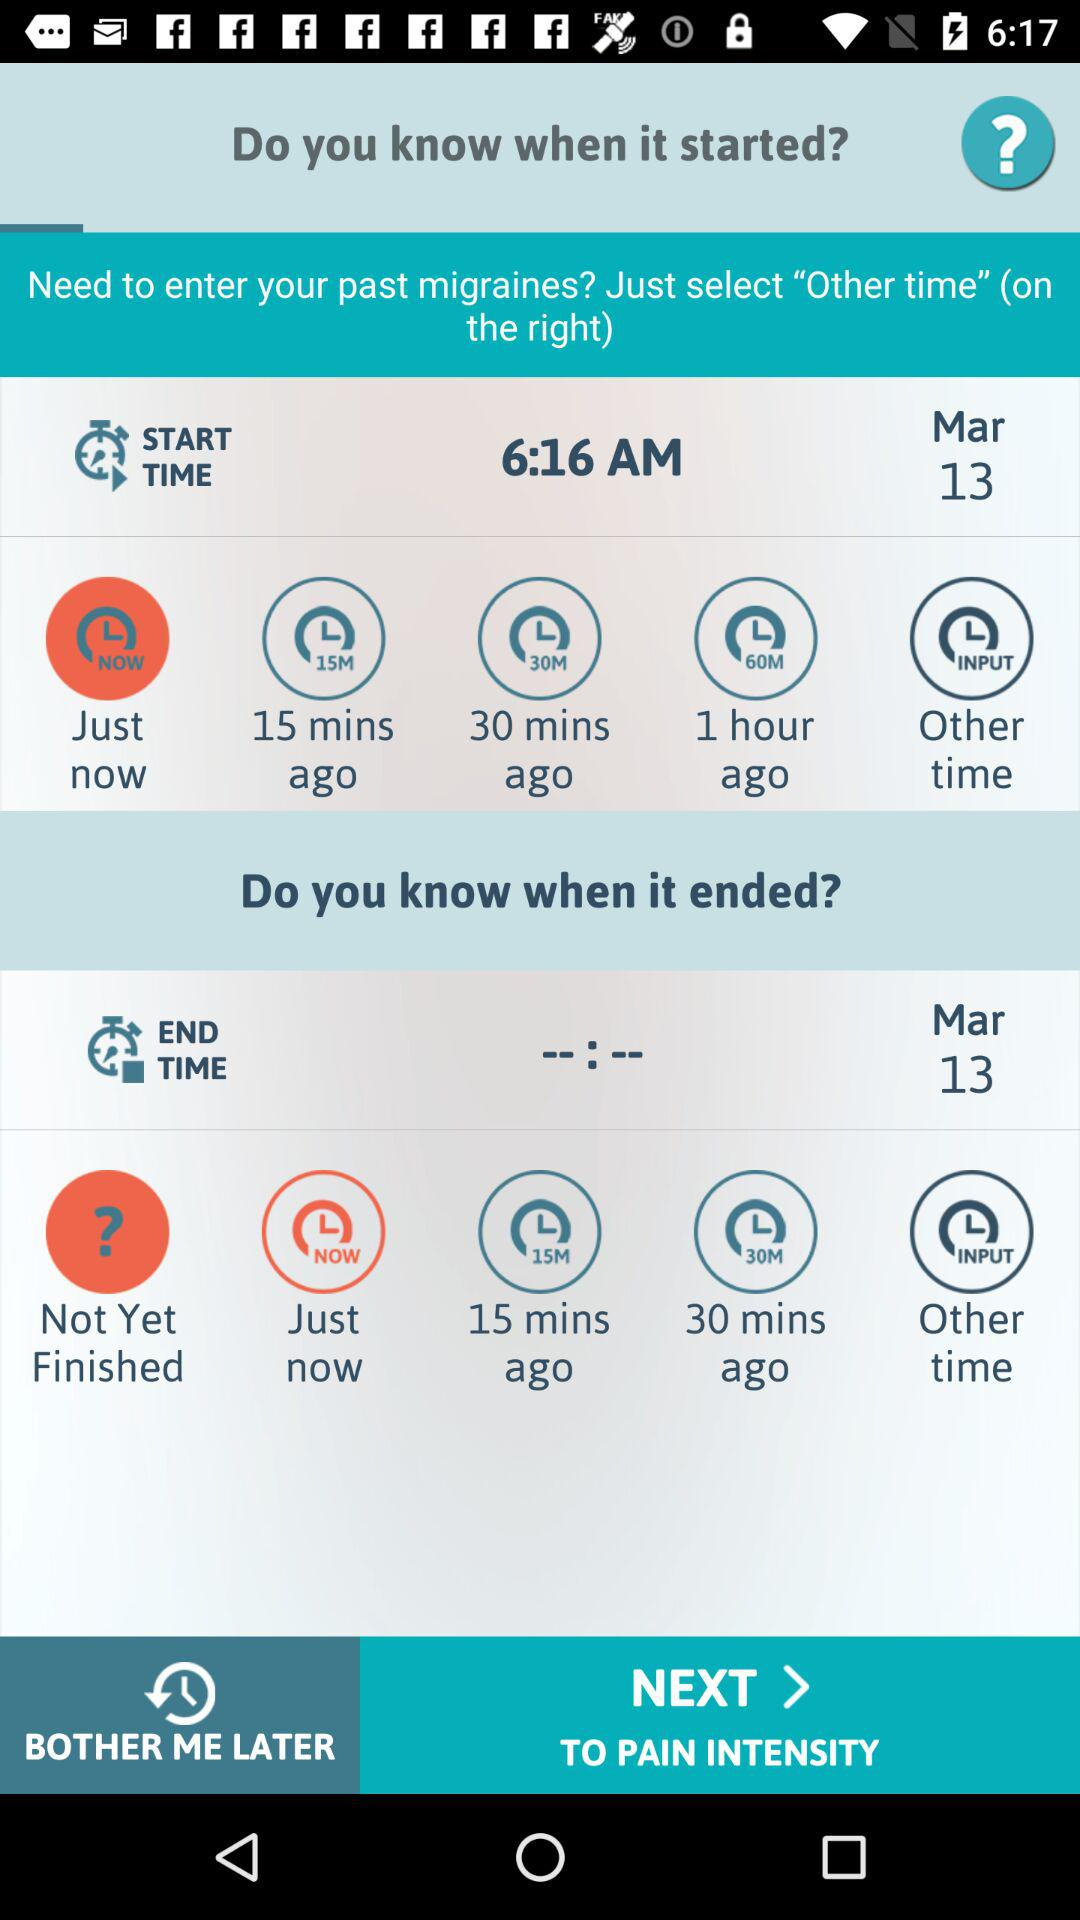What is the given date? The given date is March 13. 